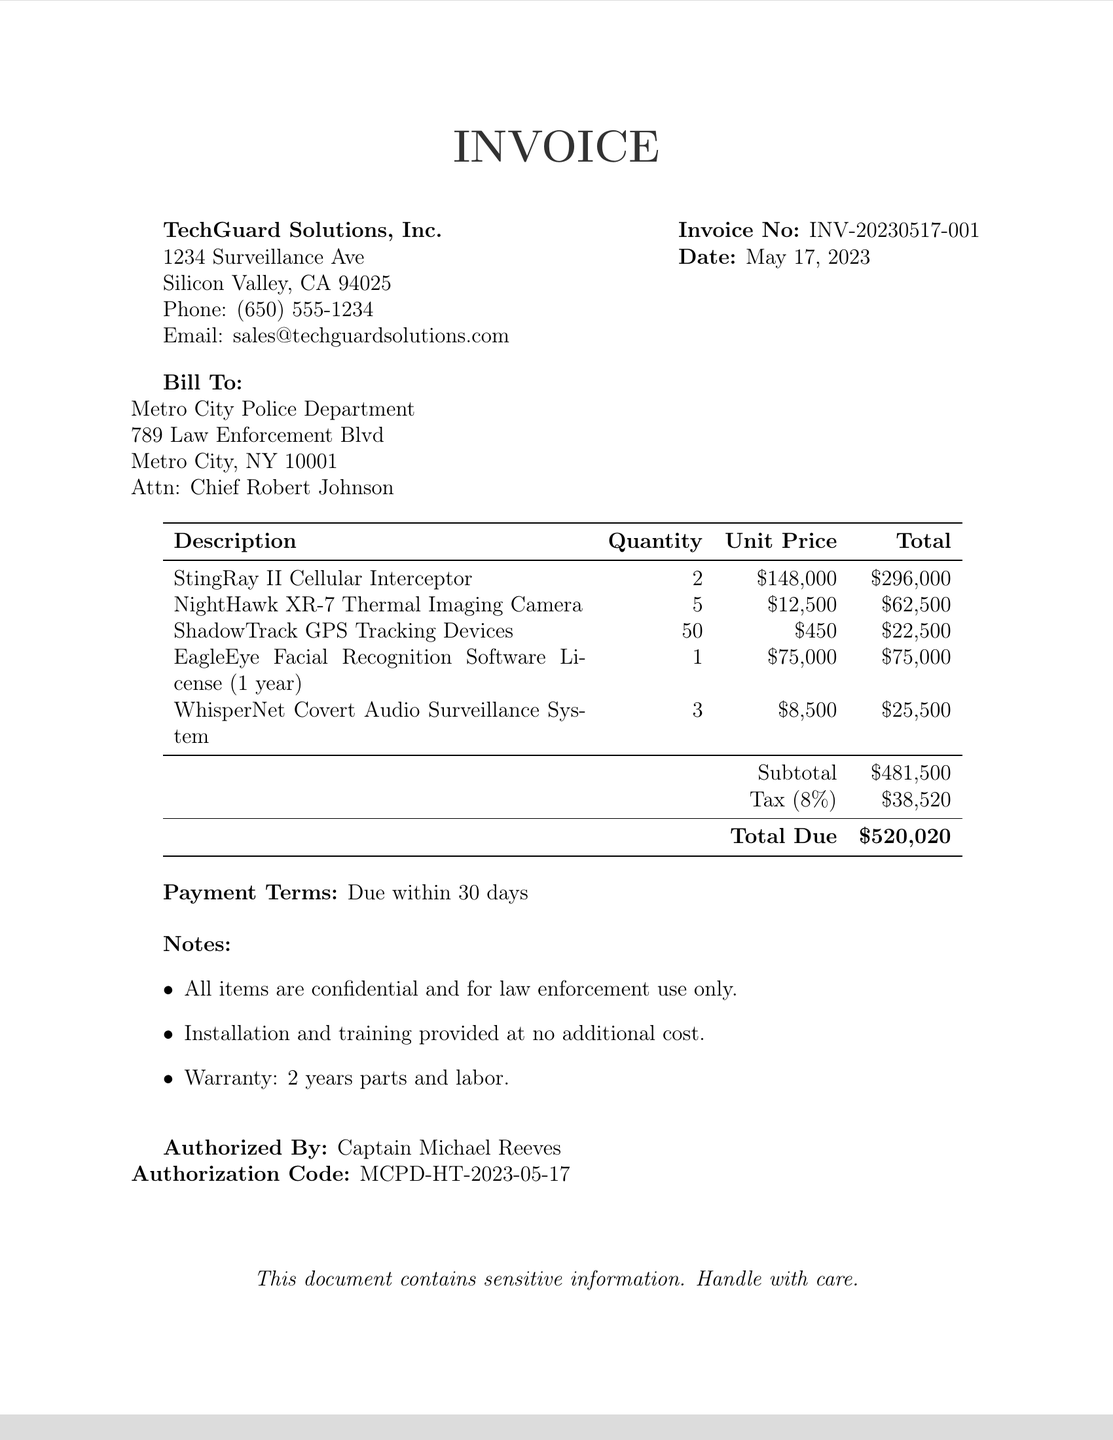What is the invoice number? The invoice number is clearly stated in the document as a unique identifier for the transaction.
Answer: INV-20230517-001 What is the total due amount? The total due amount represents the final payment expected, calculated by adding the subtotal and tax.
Answer: $520,020 Who is the vendor? The vendor is the company that provided the services and products listed in the invoice.
Answer: TechGuard Solutions, Inc What is the date of the invoice? The date indicates when the invoice was issued, which is important for record-keeping and payment terms.
Answer: May 17, 2023 How many NightHawk XR-7 Thermal Imaging Cameras were purchased? This information specifies the quantity of a particular item acquired, which is relevant to procurement verification.
Answer: 5 Who authorized the purchase? This refers to the individual responsible for approving the invoice, which is vital in assessing adherence to procurement policies.
Answer: Captain Michael Reeves What percentage is the tax rate? The tax rate is applied to determine the appropriate tax amount added to the subtotal for the invoice.
Answer: 8% Which item has the highest unit price? This identifies which purchased item is the most expensive, which can raise concerns regarding budgetary constraints.
Answer: StingRay II Cellular Interceptor Were any procurement processes followed? This question addresses the transparency and legitimacy of the purchase, relevant to potential department corruption considerations.
Answer: No 